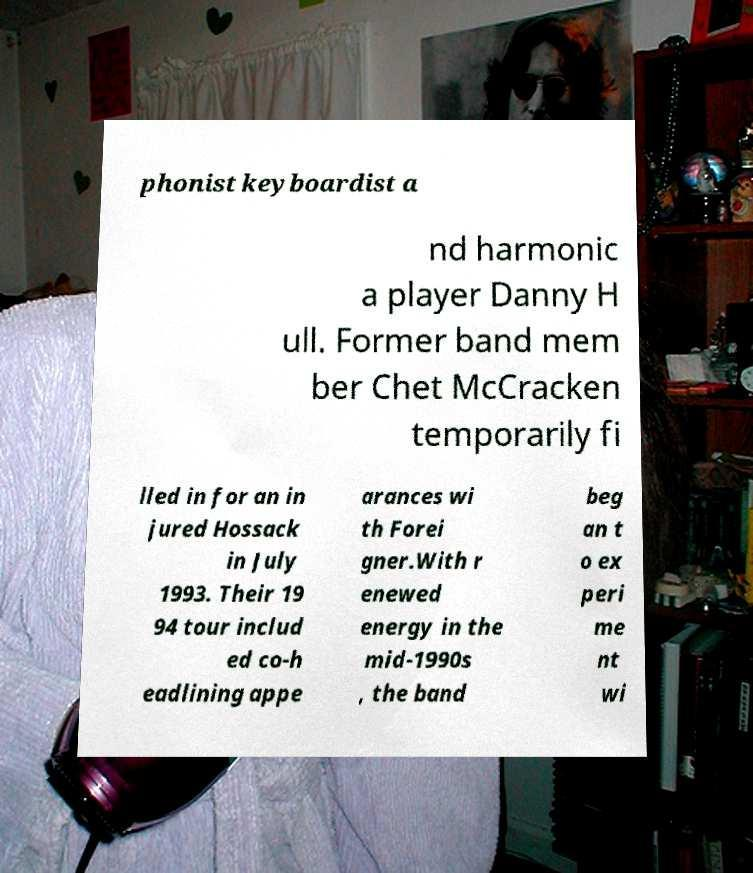Can you accurately transcribe the text from the provided image for me? phonist keyboardist a nd harmonic a player Danny H ull. Former band mem ber Chet McCracken temporarily fi lled in for an in jured Hossack in July 1993. Their 19 94 tour includ ed co-h eadlining appe arances wi th Forei gner.With r enewed energy in the mid-1990s , the band beg an t o ex peri me nt wi 